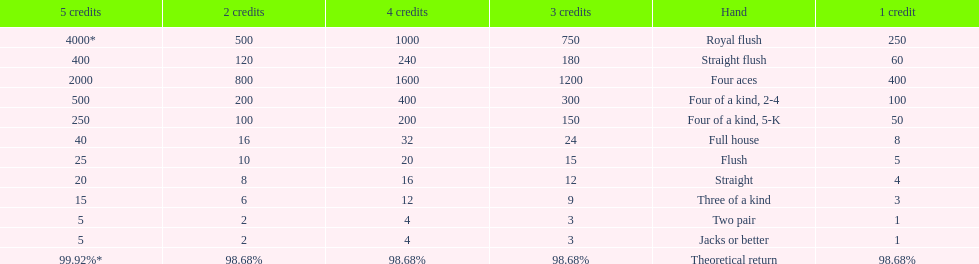After winning on four credits with a full house, what is your payout? 32. 